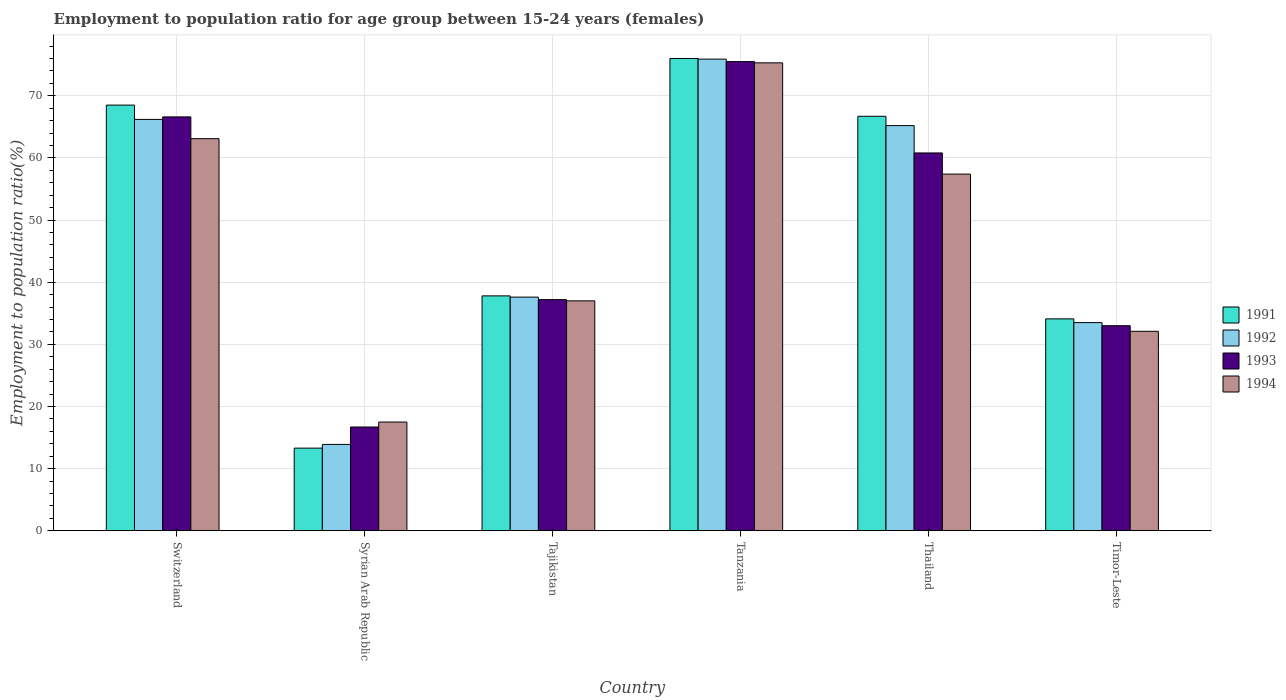How many different coloured bars are there?
Provide a succinct answer. 4. How many groups of bars are there?
Offer a very short reply. 6. Are the number of bars per tick equal to the number of legend labels?
Provide a short and direct response. Yes. How many bars are there on the 6th tick from the right?
Your answer should be compact. 4. What is the label of the 3rd group of bars from the left?
Your answer should be very brief. Tajikistan. Across all countries, what is the maximum employment to population ratio in 1994?
Keep it short and to the point. 75.3. Across all countries, what is the minimum employment to population ratio in 1992?
Offer a terse response. 13.9. In which country was the employment to population ratio in 1993 maximum?
Offer a terse response. Tanzania. In which country was the employment to population ratio in 1991 minimum?
Ensure brevity in your answer.  Syrian Arab Republic. What is the total employment to population ratio in 1991 in the graph?
Provide a short and direct response. 296.4. What is the difference between the employment to population ratio in 1991 in Tajikistan and that in Thailand?
Offer a very short reply. -28.9. What is the difference between the employment to population ratio in 1992 in Tajikistan and the employment to population ratio in 1994 in Timor-Leste?
Offer a very short reply. 5.5. What is the average employment to population ratio in 1992 per country?
Offer a very short reply. 48.72. What is the difference between the employment to population ratio of/in 1991 and employment to population ratio of/in 1993 in Thailand?
Provide a short and direct response. 5.9. In how many countries, is the employment to population ratio in 1991 greater than 26 %?
Provide a succinct answer. 5. What is the ratio of the employment to population ratio in 1991 in Switzerland to that in Thailand?
Your response must be concise. 1.03. Is the employment to population ratio in 1994 in Switzerland less than that in Thailand?
Provide a short and direct response. No. Is the difference between the employment to population ratio in 1991 in Tajikistan and Thailand greater than the difference between the employment to population ratio in 1993 in Tajikistan and Thailand?
Provide a succinct answer. No. What is the difference between the highest and the second highest employment to population ratio in 1993?
Keep it short and to the point. -8.9. What is the difference between the highest and the lowest employment to population ratio in 1991?
Offer a very short reply. 62.7. What does the 2nd bar from the left in Thailand represents?
Provide a succinct answer. 1992. What does the 1st bar from the right in Timor-Leste represents?
Give a very brief answer. 1994. Is it the case that in every country, the sum of the employment to population ratio in 1991 and employment to population ratio in 1992 is greater than the employment to population ratio in 1994?
Your answer should be compact. Yes. How many bars are there?
Your answer should be very brief. 24. Are all the bars in the graph horizontal?
Give a very brief answer. No. How many countries are there in the graph?
Offer a very short reply. 6. Are the values on the major ticks of Y-axis written in scientific E-notation?
Provide a short and direct response. No. Does the graph contain any zero values?
Give a very brief answer. No. Does the graph contain grids?
Your answer should be very brief. Yes. Where does the legend appear in the graph?
Your answer should be compact. Center right. How many legend labels are there?
Your answer should be compact. 4. How are the legend labels stacked?
Your response must be concise. Vertical. What is the title of the graph?
Provide a succinct answer. Employment to population ratio for age group between 15-24 years (females). What is the label or title of the X-axis?
Your response must be concise. Country. What is the label or title of the Y-axis?
Offer a very short reply. Employment to population ratio(%). What is the Employment to population ratio(%) of 1991 in Switzerland?
Ensure brevity in your answer.  68.5. What is the Employment to population ratio(%) of 1992 in Switzerland?
Ensure brevity in your answer.  66.2. What is the Employment to population ratio(%) of 1993 in Switzerland?
Give a very brief answer. 66.6. What is the Employment to population ratio(%) of 1994 in Switzerland?
Offer a terse response. 63.1. What is the Employment to population ratio(%) of 1991 in Syrian Arab Republic?
Your answer should be very brief. 13.3. What is the Employment to population ratio(%) of 1992 in Syrian Arab Republic?
Provide a short and direct response. 13.9. What is the Employment to population ratio(%) in 1993 in Syrian Arab Republic?
Make the answer very short. 16.7. What is the Employment to population ratio(%) of 1994 in Syrian Arab Republic?
Provide a succinct answer. 17.5. What is the Employment to population ratio(%) in 1991 in Tajikistan?
Keep it short and to the point. 37.8. What is the Employment to population ratio(%) in 1992 in Tajikistan?
Provide a short and direct response. 37.6. What is the Employment to population ratio(%) in 1993 in Tajikistan?
Provide a short and direct response. 37.2. What is the Employment to population ratio(%) in 1991 in Tanzania?
Provide a succinct answer. 76. What is the Employment to population ratio(%) of 1992 in Tanzania?
Offer a very short reply. 75.9. What is the Employment to population ratio(%) in 1993 in Tanzania?
Your answer should be very brief. 75.5. What is the Employment to population ratio(%) in 1994 in Tanzania?
Give a very brief answer. 75.3. What is the Employment to population ratio(%) in 1991 in Thailand?
Make the answer very short. 66.7. What is the Employment to population ratio(%) of 1992 in Thailand?
Offer a very short reply. 65.2. What is the Employment to population ratio(%) in 1993 in Thailand?
Your answer should be compact. 60.8. What is the Employment to population ratio(%) of 1994 in Thailand?
Provide a short and direct response. 57.4. What is the Employment to population ratio(%) in 1991 in Timor-Leste?
Give a very brief answer. 34.1. What is the Employment to population ratio(%) in 1992 in Timor-Leste?
Provide a succinct answer. 33.5. What is the Employment to population ratio(%) in 1994 in Timor-Leste?
Your response must be concise. 32.1. Across all countries, what is the maximum Employment to population ratio(%) in 1991?
Your response must be concise. 76. Across all countries, what is the maximum Employment to population ratio(%) in 1992?
Offer a very short reply. 75.9. Across all countries, what is the maximum Employment to population ratio(%) of 1993?
Make the answer very short. 75.5. Across all countries, what is the maximum Employment to population ratio(%) in 1994?
Your response must be concise. 75.3. Across all countries, what is the minimum Employment to population ratio(%) of 1991?
Your answer should be compact. 13.3. Across all countries, what is the minimum Employment to population ratio(%) of 1992?
Ensure brevity in your answer.  13.9. Across all countries, what is the minimum Employment to population ratio(%) in 1993?
Provide a short and direct response. 16.7. Across all countries, what is the minimum Employment to population ratio(%) of 1994?
Give a very brief answer. 17.5. What is the total Employment to population ratio(%) in 1991 in the graph?
Your answer should be compact. 296.4. What is the total Employment to population ratio(%) in 1992 in the graph?
Keep it short and to the point. 292.3. What is the total Employment to population ratio(%) in 1993 in the graph?
Make the answer very short. 289.8. What is the total Employment to population ratio(%) of 1994 in the graph?
Offer a very short reply. 282.4. What is the difference between the Employment to population ratio(%) of 1991 in Switzerland and that in Syrian Arab Republic?
Make the answer very short. 55.2. What is the difference between the Employment to population ratio(%) in 1992 in Switzerland and that in Syrian Arab Republic?
Your answer should be very brief. 52.3. What is the difference between the Employment to population ratio(%) of 1993 in Switzerland and that in Syrian Arab Republic?
Offer a terse response. 49.9. What is the difference between the Employment to population ratio(%) in 1994 in Switzerland and that in Syrian Arab Republic?
Offer a very short reply. 45.6. What is the difference between the Employment to population ratio(%) in 1991 in Switzerland and that in Tajikistan?
Provide a short and direct response. 30.7. What is the difference between the Employment to population ratio(%) of 1992 in Switzerland and that in Tajikistan?
Your answer should be compact. 28.6. What is the difference between the Employment to population ratio(%) in 1993 in Switzerland and that in Tajikistan?
Your response must be concise. 29.4. What is the difference between the Employment to population ratio(%) in 1994 in Switzerland and that in Tajikistan?
Provide a succinct answer. 26.1. What is the difference between the Employment to population ratio(%) of 1991 in Switzerland and that in Tanzania?
Your response must be concise. -7.5. What is the difference between the Employment to population ratio(%) of 1992 in Switzerland and that in Tanzania?
Offer a terse response. -9.7. What is the difference between the Employment to population ratio(%) in 1993 in Switzerland and that in Tanzania?
Provide a short and direct response. -8.9. What is the difference between the Employment to population ratio(%) in 1994 in Switzerland and that in Thailand?
Offer a very short reply. 5.7. What is the difference between the Employment to population ratio(%) of 1991 in Switzerland and that in Timor-Leste?
Make the answer very short. 34.4. What is the difference between the Employment to population ratio(%) in 1992 in Switzerland and that in Timor-Leste?
Provide a succinct answer. 32.7. What is the difference between the Employment to population ratio(%) of 1993 in Switzerland and that in Timor-Leste?
Offer a very short reply. 33.6. What is the difference between the Employment to population ratio(%) in 1991 in Syrian Arab Republic and that in Tajikistan?
Make the answer very short. -24.5. What is the difference between the Employment to population ratio(%) of 1992 in Syrian Arab Republic and that in Tajikistan?
Your answer should be compact. -23.7. What is the difference between the Employment to population ratio(%) of 1993 in Syrian Arab Republic and that in Tajikistan?
Provide a succinct answer. -20.5. What is the difference between the Employment to population ratio(%) of 1994 in Syrian Arab Republic and that in Tajikistan?
Provide a succinct answer. -19.5. What is the difference between the Employment to population ratio(%) of 1991 in Syrian Arab Republic and that in Tanzania?
Offer a terse response. -62.7. What is the difference between the Employment to population ratio(%) of 1992 in Syrian Arab Republic and that in Tanzania?
Your response must be concise. -62. What is the difference between the Employment to population ratio(%) in 1993 in Syrian Arab Republic and that in Tanzania?
Provide a succinct answer. -58.8. What is the difference between the Employment to population ratio(%) in 1994 in Syrian Arab Republic and that in Tanzania?
Your answer should be very brief. -57.8. What is the difference between the Employment to population ratio(%) in 1991 in Syrian Arab Republic and that in Thailand?
Provide a short and direct response. -53.4. What is the difference between the Employment to population ratio(%) of 1992 in Syrian Arab Republic and that in Thailand?
Ensure brevity in your answer.  -51.3. What is the difference between the Employment to population ratio(%) of 1993 in Syrian Arab Republic and that in Thailand?
Offer a very short reply. -44.1. What is the difference between the Employment to population ratio(%) of 1994 in Syrian Arab Republic and that in Thailand?
Give a very brief answer. -39.9. What is the difference between the Employment to population ratio(%) of 1991 in Syrian Arab Republic and that in Timor-Leste?
Keep it short and to the point. -20.8. What is the difference between the Employment to population ratio(%) of 1992 in Syrian Arab Republic and that in Timor-Leste?
Your answer should be compact. -19.6. What is the difference between the Employment to population ratio(%) of 1993 in Syrian Arab Republic and that in Timor-Leste?
Provide a succinct answer. -16.3. What is the difference between the Employment to population ratio(%) in 1994 in Syrian Arab Republic and that in Timor-Leste?
Your answer should be compact. -14.6. What is the difference between the Employment to population ratio(%) of 1991 in Tajikistan and that in Tanzania?
Your answer should be compact. -38.2. What is the difference between the Employment to population ratio(%) of 1992 in Tajikistan and that in Tanzania?
Your answer should be compact. -38.3. What is the difference between the Employment to population ratio(%) of 1993 in Tajikistan and that in Tanzania?
Provide a succinct answer. -38.3. What is the difference between the Employment to population ratio(%) in 1994 in Tajikistan and that in Tanzania?
Make the answer very short. -38.3. What is the difference between the Employment to population ratio(%) in 1991 in Tajikistan and that in Thailand?
Provide a short and direct response. -28.9. What is the difference between the Employment to population ratio(%) of 1992 in Tajikistan and that in Thailand?
Ensure brevity in your answer.  -27.6. What is the difference between the Employment to population ratio(%) of 1993 in Tajikistan and that in Thailand?
Ensure brevity in your answer.  -23.6. What is the difference between the Employment to population ratio(%) in 1994 in Tajikistan and that in Thailand?
Your response must be concise. -20.4. What is the difference between the Employment to population ratio(%) of 1992 in Tajikistan and that in Timor-Leste?
Your response must be concise. 4.1. What is the difference between the Employment to population ratio(%) of 1993 in Tajikistan and that in Timor-Leste?
Offer a very short reply. 4.2. What is the difference between the Employment to population ratio(%) of 1994 in Tajikistan and that in Timor-Leste?
Your answer should be very brief. 4.9. What is the difference between the Employment to population ratio(%) in 1991 in Tanzania and that in Thailand?
Offer a terse response. 9.3. What is the difference between the Employment to population ratio(%) in 1992 in Tanzania and that in Thailand?
Your answer should be compact. 10.7. What is the difference between the Employment to population ratio(%) in 1993 in Tanzania and that in Thailand?
Give a very brief answer. 14.7. What is the difference between the Employment to population ratio(%) in 1994 in Tanzania and that in Thailand?
Your answer should be compact. 17.9. What is the difference between the Employment to population ratio(%) of 1991 in Tanzania and that in Timor-Leste?
Provide a succinct answer. 41.9. What is the difference between the Employment to population ratio(%) of 1992 in Tanzania and that in Timor-Leste?
Provide a short and direct response. 42.4. What is the difference between the Employment to population ratio(%) of 1993 in Tanzania and that in Timor-Leste?
Offer a terse response. 42.5. What is the difference between the Employment to population ratio(%) in 1994 in Tanzania and that in Timor-Leste?
Ensure brevity in your answer.  43.2. What is the difference between the Employment to population ratio(%) of 1991 in Thailand and that in Timor-Leste?
Ensure brevity in your answer.  32.6. What is the difference between the Employment to population ratio(%) of 1992 in Thailand and that in Timor-Leste?
Give a very brief answer. 31.7. What is the difference between the Employment to population ratio(%) of 1993 in Thailand and that in Timor-Leste?
Your answer should be very brief. 27.8. What is the difference between the Employment to population ratio(%) of 1994 in Thailand and that in Timor-Leste?
Provide a succinct answer. 25.3. What is the difference between the Employment to population ratio(%) in 1991 in Switzerland and the Employment to population ratio(%) in 1992 in Syrian Arab Republic?
Offer a terse response. 54.6. What is the difference between the Employment to population ratio(%) of 1991 in Switzerland and the Employment to population ratio(%) of 1993 in Syrian Arab Republic?
Your answer should be very brief. 51.8. What is the difference between the Employment to population ratio(%) of 1992 in Switzerland and the Employment to population ratio(%) of 1993 in Syrian Arab Republic?
Your answer should be compact. 49.5. What is the difference between the Employment to population ratio(%) in 1992 in Switzerland and the Employment to population ratio(%) in 1994 in Syrian Arab Republic?
Your response must be concise. 48.7. What is the difference between the Employment to population ratio(%) in 1993 in Switzerland and the Employment to population ratio(%) in 1994 in Syrian Arab Republic?
Provide a short and direct response. 49.1. What is the difference between the Employment to population ratio(%) in 1991 in Switzerland and the Employment to population ratio(%) in 1992 in Tajikistan?
Give a very brief answer. 30.9. What is the difference between the Employment to population ratio(%) of 1991 in Switzerland and the Employment to population ratio(%) of 1993 in Tajikistan?
Offer a very short reply. 31.3. What is the difference between the Employment to population ratio(%) in 1991 in Switzerland and the Employment to population ratio(%) in 1994 in Tajikistan?
Provide a short and direct response. 31.5. What is the difference between the Employment to population ratio(%) of 1992 in Switzerland and the Employment to population ratio(%) of 1993 in Tajikistan?
Provide a succinct answer. 29. What is the difference between the Employment to population ratio(%) in 1992 in Switzerland and the Employment to population ratio(%) in 1994 in Tajikistan?
Offer a very short reply. 29.2. What is the difference between the Employment to population ratio(%) in 1993 in Switzerland and the Employment to population ratio(%) in 1994 in Tajikistan?
Make the answer very short. 29.6. What is the difference between the Employment to population ratio(%) of 1991 in Switzerland and the Employment to population ratio(%) of 1992 in Tanzania?
Give a very brief answer. -7.4. What is the difference between the Employment to population ratio(%) in 1991 in Switzerland and the Employment to population ratio(%) in 1993 in Tanzania?
Your answer should be compact. -7. What is the difference between the Employment to population ratio(%) in 1992 in Switzerland and the Employment to population ratio(%) in 1993 in Tanzania?
Make the answer very short. -9.3. What is the difference between the Employment to population ratio(%) in 1991 in Switzerland and the Employment to population ratio(%) in 1994 in Thailand?
Your response must be concise. 11.1. What is the difference between the Employment to population ratio(%) in 1992 in Switzerland and the Employment to population ratio(%) in 1993 in Thailand?
Ensure brevity in your answer.  5.4. What is the difference between the Employment to population ratio(%) of 1992 in Switzerland and the Employment to population ratio(%) of 1994 in Thailand?
Your answer should be compact. 8.8. What is the difference between the Employment to population ratio(%) in 1991 in Switzerland and the Employment to population ratio(%) in 1992 in Timor-Leste?
Your response must be concise. 35. What is the difference between the Employment to population ratio(%) in 1991 in Switzerland and the Employment to population ratio(%) in 1993 in Timor-Leste?
Offer a very short reply. 35.5. What is the difference between the Employment to population ratio(%) of 1991 in Switzerland and the Employment to population ratio(%) of 1994 in Timor-Leste?
Provide a short and direct response. 36.4. What is the difference between the Employment to population ratio(%) of 1992 in Switzerland and the Employment to population ratio(%) of 1993 in Timor-Leste?
Keep it short and to the point. 33.2. What is the difference between the Employment to population ratio(%) in 1992 in Switzerland and the Employment to population ratio(%) in 1994 in Timor-Leste?
Provide a succinct answer. 34.1. What is the difference between the Employment to population ratio(%) in 1993 in Switzerland and the Employment to population ratio(%) in 1994 in Timor-Leste?
Provide a short and direct response. 34.5. What is the difference between the Employment to population ratio(%) of 1991 in Syrian Arab Republic and the Employment to population ratio(%) of 1992 in Tajikistan?
Offer a terse response. -24.3. What is the difference between the Employment to population ratio(%) of 1991 in Syrian Arab Republic and the Employment to population ratio(%) of 1993 in Tajikistan?
Make the answer very short. -23.9. What is the difference between the Employment to population ratio(%) of 1991 in Syrian Arab Republic and the Employment to population ratio(%) of 1994 in Tajikistan?
Your response must be concise. -23.7. What is the difference between the Employment to population ratio(%) of 1992 in Syrian Arab Republic and the Employment to population ratio(%) of 1993 in Tajikistan?
Provide a succinct answer. -23.3. What is the difference between the Employment to population ratio(%) of 1992 in Syrian Arab Republic and the Employment to population ratio(%) of 1994 in Tajikistan?
Your response must be concise. -23.1. What is the difference between the Employment to population ratio(%) of 1993 in Syrian Arab Republic and the Employment to population ratio(%) of 1994 in Tajikistan?
Provide a succinct answer. -20.3. What is the difference between the Employment to population ratio(%) of 1991 in Syrian Arab Republic and the Employment to population ratio(%) of 1992 in Tanzania?
Your answer should be compact. -62.6. What is the difference between the Employment to population ratio(%) of 1991 in Syrian Arab Republic and the Employment to population ratio(%) of 1993 in Tanzania?
Your answer should be very brief. -62.2. What is the difference between the Employment to population ratio(%) in 1991 in Syrian Arab Republic and the Employment to population ratio(%) in 1994 in Tanzania?
Your response must be concise. -62. What is the difference between the Employment to population ratio(%) of 1992 in Syrian Arab Republic and the Employment to population ratio(%) of 1993 in Tanzania?
Your answer should be very brief. -61.6. What is the difference between the Employment to population ratio(%) in 1992 in Syrian Arab Republic and the Employment to population ratio(%) in 1994 in Tanzania?
Offer a terse response. -61.4. What is the difference between the Employment to population ratio(%) in 1993 in Syrian Arab Republic and the Employment to population ratio(%) in 1994 in Tanzania?
Your response must be concise. -58.6. What is the difference between the Employment to population ratio(%) of 1991 in Syrian Arab Republic and the Employment to population ratio(%) of 1992 in Thailand?
Keep it short and to the point. -51.9. What is the difference between the Employment to population ratio(%) of 1991 in Syrian Arab Republic and the Employment to population ratio(%) of 1993 in Thailand?
Offer a terse response. -47.5. What is the difference between the Employment to population ratio(%) in 1991 in Syrian Arab Republic and the Employment to population ratio(%) in 1994 in Thailand?
Offer a terse response. -44.1. What is the difference between the Employment to population ratio(%) in 1992 in Syrian Arab Republic and the Employment to population ratio(%) in 1993 in Thailand?
Offer a very short reply. -46.9. What is the difference between the Employment to population ratio(%) in 1992 in Syrian Arab Republic and the Employment to population ratio(%) in 1994 in Thailand?
Your answer should be compact. -43.5. What is the difference between the Employment to population ratio(%) of 1993 in Syrian Arab Republic and the Employment to population ratio(%) of 1994 in Thailand?
Your answer should be compact. -40.7. What is the difference between the Employment to population ratio(%) in 1991 in Syrian Arab Republic and the Employment to population ratio(%) in 1992 in Timor-Leste?
Give a very brief answer. -20.2. What is the difference between the Employment to population ratio(%) in 1991 in Syrian Arab Republic and the Employment to population ratio(%) in 1993 in Timor-Leste?
Provide a succinct answer. -19.7. What is the difference between the Employment to population ratio(%) of 1991 in Syrian Arab Republic and the Employment to population ratio(%) of 1994 in Timor-Leste?
Keep it short and to the point. -18.8. What is the difference between the Employment to population ratio(%) in 1992 in Syrian Arab Republic and the Employment to population ratio(%) in 1993 in Timor-Leste?
Make the answer very short. -19.1. What is the difference between the Employment to population ratio(%) of 1992 in Syrian Arab Republic and the Employment to population ratio(%) of 1994 in Timor-Leste?
Your response must be concise. -18.2. What is the difference between the Employment to population ratio(%) of 1993 in Syrian Arab Republic and the Employment to population ratio(%) of 1994 in Timor-Leste?
Ensure brevity in your answer.  -15.4. What is the difference between the Employment to population ratio(%) of 1991 in Tajikistan and the Employment to population ratio(%) of 1992 in Tanzania?
Ensure brevity in your answer.  -38.1. What is the difference between the Employment to population ratio(%) in 1991 in Tajikistan and the Employment to population ratio(%) in 1993 in Tanzania?
Provide a succinct answer. -37.7. What is the difference between the Employment to population ratio(%) of 1991 in Tajikistan and the Employment to population ratio(%) of 1994 in Tanzania?
Provide a short and direct response. -37.5. What is the difference between the Employment to population ratio(%) of 1992 in Tajikistan and the Employment to population ratio(%) of 1993 in Tanzania?
Your response must be concise. -37.9. What is the difference between the Employment to population ratio(%) of 1992 in Tajikistan and the Employment to population ratio(%) of 1994 in Tanzania?
Make the answer very short. -37.7. What is the difference between the Employment to population ratio(%) in 1993 in Tajikistan and the Employment to population ratio(%) in 1994 in Tanzania?
Your answer should be very brief. -38.1. What is the difference between the Employment to population ratio(%) of 1991 in Tajikistan and the Employment to population ratio(%) of 1992 in Thailand?
Your response must be concise. -27.4. What is the difference between the Employment to population ratio(%) of 1991 in Tajikistan and the Employment to population ratio(%) of 1994 in Thailand?
Provide a succinct answer. -19.6. What is the difference between the Employment to population ratio(%) in 1992 in Tajikistan and the Employment to population ratio(%) in 1993 in Thailand?
Your response must be concise. -23.2. What is the difference between the Employment to population ratio(%) of 1992 in Tajikistan and the Employment to population ratio(%) of 1994 in Thailand?
Keep it short and to the point. -19.8. What is the difference between the Employment to population ratio(%) in 1993 in Tajikistan and the Employment to population ratio(%) in 1994 in Thailand?
Provide a short and direct response. -20.2. What is the difference between the Employment to population ratio(%) in 1991 in Tajikistan and the Employment to population ratio(%) in 1994 in Timor-Leste?
Your answer should be compact. 5.7. What is the difference between the Employment to population ratio(%) in 1993 in Tajikistan and the Employment to population ratio(%) in 1994 in Timor-Leste?
Provide a short and direct response. 5.1. What is the difference between the Employment to population ratio(%) in 1991 in Tanzania and the Employment to population ratio(%) in 1993 in Thailand?
Your answer should be compact. 15.2. What is the difference between the Employment to population ratio(%) of 1991 in Tanzania and the Employment to population ratio(%) of 1994 in Thailand?
Make the answer very short. 18.6. What is the difference between the Employment to population ratio(%) in 1992 in Tanzania and the Employment to population ratio(%) in 1993 in Thailand?
Your answer should be compact. 15.1. What is the difference between the Employment to population ratio(%) in 1993 in Tanzania and the Employment to population ratio(%) in 1994 in Thailand?
Give a very brief answer. 18.1. What is the difference between the Employment to population ratio(%) in 1991 in Tanzania and the Employment to population ratio(%) in 1992 in Timor-Leste?
Give a very brief answer. 42.5. What is the difference between the Employment to population ratio(%) of 1991 in Tanzania and the Employment to population ratio(%) of 1994 in Timor-Leste?
Keep it short and to the point. 43.9. What is the difference between the Employment to population ratio(%) of 1992 in Tanzania and the Employment to population ratio(%) of 1993 in Timor-Leste?
Your answer should be very brief. 42.9. What is the difference between the Employment to population ratio(%) of 1992 in Tanzania and the Employment to population ratio(%) of 1994 in Timor-Leste?
Offer a very short reply. 43.8. What is the difference between the Employment to population ratio(%) of 1993 in Tanzania and the Employment to population ratio(%) of 1994 in Timor-Leste?
Ensure brevity in your answer.  43.4. What is the difference between the Employment to population ratio(%) in 1991 in Thailand and the Employment to population ratio(%) in 1992 in Timor-Leste?
Keep it short and to the point. 33.2. What is the difference between the Employment to population ratio(%) of 1991 in Thailand and the Employment to population ratio(%) of 1993 in Timor-Leste?
Keep it short and to the point. 33.7. What is the difference between the Employment to population ratio(%) in 1991 in Thailand and the Employment to population ratio(%) in 1994 in Timor-Leste?
Give a very brief answer. 34.6. What is the difference between the Employment to population ratio(%) of 1992 in Thailand and the Employment to population ratio(%) of 1993 in Timor-Leste?
Your answer should be very brief. 32.2. What is the difference between the Employment to population ratio(%) in 1992 in Thailand and the Employment to population ratio(%) in 1994 in Timor-Leste?
Provide a short and direct response. 33.1. What is the difference between the Employment to population ratio(%) of 1993 in Thailand and the Employment to population ratio(%) of 1994 in Timor-Leste?
Give a very brief answer. 28.7. What is the average Employment to population ratio(%) in 1991 per country?
Give a very brief answer. 49.4. What is the average Employment to population ratio(%) of 1992 per country?
Your response must be concise. 48.72. What is the average Employment to population ratio(%) in 1993 per country?
Provide a succinct answer. 48.3. What is the average Employment to population ratio(%) in 1994 per country?
Offer a very short reply. 47.07. What is the difference between the Employment to population ratio(%) of 1991 and Employment to population ratio(%) of 1993 in Switzerland?
Your answer should be very brief. 1.9. What is the difference between the Employment to population ratio(%) of 1991 and Employment to population ratio(%) of 1994 in Switzerland?
Your response must be concise. 5.4. What is the difference between the Employment to population ratio(%) of 1992 and Employment to population ratio(%) of 1993 in Switzerland?
Make the answer very short. -0.4. What is the difference between the Employment to population ratio(%) of 1992 and Employment to population ratio(%) of 1994 in Switzerland?
Offer a very short reply. 3.1. What is the difference between the Employment to population ratio(%) in 1993 and Employment to population ratio(%) in 1994 in Switzerland?
Make the answer very short. 3.5. What is the difference between the Employment to population ratio(%) in 1991 and Employment to population ratio(%) in 1992 in Syrian Arab Republic?
Make the answer very short. -0.6. What is the difference between the Employment to population ratio(%) in 1991 and Employment to population ratio(%) in 1994 in Syrian Arab Republic?
Provide a succinct answer. -4.2. What is the difference between the Employment to population ratio(%) in 1992 and Employment to population ratio(%) in 1993 in Syrian Arab Republic?
Keep it short and to the point. -2.8. What is the difference between the Employment to population ratio(%) of 1992 and Employment to population ratio(%) of 1994 in Syrian Arab Republic?
Your answer should be compact. -3.6. What is the difference between the Employment to population ratio(%) in 1993 and Employment to population ratio(%) in 1994 in Syrian Arab Republic?
Offer a terse response. -0.8. What is the difference between the Employment to population ratio(%) in 1991 and Employment to population ratio(%) in 1992 in Tajikistan?
Keep it short and to the point. 0.2. What is the difference between the Employment to population ratio(%) of 1991 and Employment to population ratio(%) of 1993 in Tajikistan?
Ensure brevity in your answer.  0.6. What is the difference between the Employment to population ratio(%) in 1991 and Employment to population ratio(%) in 1992 in Tanzania?
Offer a very short reply. 0.1. What is the difference between the Employment to population ratio(%) in 1991 and Employment to population ratio(%) in 1994 in Tanzania?
Your answer should be compact. 0.7. What is the difference between the Employment to population ratio(%) in 1992 and Employment to population ratio(%) in 1994 in Tanzania?
Provide a short and direct response. 0.6. What is the difference between the Employment to population ratio(%) in 1991 and Employment to population ratio(%) in 1992 in Thailand?
Offer a very short reply. 1.5. What is the difference between the Employment to population ratio(%) in 1991 and Employment to population ratio(%) in 1993 in Thailand?
Offer a very short reply. 5.9. What is the difference between the Employment to population ratio(%) of 1991 and Employment to population ratio(%) of 1994 in Thailand?
Offer a very short reply. 9.3. What is the difference between the Employment to population ratio(%) of 1992 and Employment to population ratio(%) of 1993 in Thailand?
Your answer should be very brief. 4.4. What is the difference between the Employment to population ratio(%) of 1992 and Employment to population ratio(%) of 1993 in Timor-Leste?
Give a very brief answer. 0.5. What is the ratio of the Employment to population ratio(%) in 1991 in Switzerland to that in Syrian Arab Republic?
Your answer should be very brief. 5.15. What is the ratio of the Employment to population ratio(%) of 1992 in Switzerland to that in Syrian Arab Republic?
Give a very brief answer. 4.76. What is the ratio of the Employment to population ratio(%) of 1993 in Switzerland to that in Syrian Arab Republic?
Provide a succinct answer. 3.99. What is the ratio of the Employment to population ratio(%) in 1994 in Switzerland to that in Syrian Arab Republic?
Offer a terse response. 3.61. What is the ratio of the Employment to population ratio(%) of 1991 in Switzerland to that in Tajikistan?
Your answer should be very brief. 1.81. What is the ratio of the Employment to population ratio(%) in 1992 in Switzerland to that in Tajikistan?
Your response must be concise. 1.76. What is the ratio of the Employment to population ratio(%) of 1993 in Switzerland to that in Tajikistan?
Provide a short and direct response. 1.79. What is the ratio of the Employment to population ratio(%) in 1994 in Switzerland to that in Tajikistan?
Provide a succinct answer. 1.71. What is the ratio of the Employment to population ratio(%) in 1991 in Switzerland to that in Tanzania?
Ensure brevity in your answer.  0.9. What is the ratio of the Employment to population ratio(%) of 1992 in Switzerland to that in Tanzania?
Your answer should be compact. 0.87. What is the ratio of the Employment to population ratio(%) of 1993 in Switzerland to that in Tanzania?
Provide a short and direct response. 0.88. What is the ratio of the Employment to population ratio(%) in 1994 in Switzerland to that in Tanzania?
Ensure brevity in your answer.  0.84. What is the ratio of the Employment to population ratio(%) in 1991 in Switzerland to that in Thailand?
Offer a very short reply. 1.03. What is the ratio of the Employment to population ratio(%) of 1992 in Switzerland to that in Thailand?
Keep it short and to the point. 1.02. What is the ratio of the Employment to population ratio(%) in 1993 in Switzerland to that in Thailand?
Give a very brief answer. 1.1. What is the ratio of the Employment to population ratio(%) of 1994 in Switzerland to that in Thailand?
Your answer should be compact. 1.1. What is the ratio of the Employment to population ratio(%) of 1991 in Switzerland to that in Timor-Leste?
Your answer should be compact. 2.01. What is the ratio of the Employment to population ratio(%) in 1992 in Switzerland to that in Timor-Leste?
Offer a terse response. 1.98. What is the ratio of the Employment to population ratio(%) of 1993 in Switzerland to that in Timor-Leste?
Ensure brevity in your answer.  2.02. What is the ratio of the Employment to population ratio(%) of 1994 in Switzerland to that in Timor-Leste?
Your answer should be compact. 1.97. What is the ratio of the Employment to population ratio(%) of 1991 in Syrian Arab Republic to that in Tajikistan?
Ensure brevity in your answer.  0.35. What is the ratio of the Employment to population ratio(%) of 1992 in Syrian Arab Republic to that in Tajikistan?
Offer a terse response. 0.37. What is the ratio of the Employment to population ratio(%) in 1993 in Syrian Arab Republic to that in Tajikistan?
Give a very brief answer. 0.45. What is the ratio of the Employment to population ratio(%) in 1994 in Syrian Arab Republic to that in Tajikistan?
Offer a terse response. 0.47. What is the ratio of the Employment to population ratio(%) of 1991 in Syrian Arab Republic to that in Tanzania?
Your answer should be very brief. 0.17. What is the ratio of the Employment to population ratio(%) in 1992 in Syrian Arab Republic to that in Tanzania?
Offer a very short reply. 0.18. What is the ratio of the Employment to population ratio(%) in 1993 in Syrian Arab Republic to that in Tanzania?
Your answer should be compact. 0.22. What is the ratio of the Employment to population ratio(%) of 1994 in Syrian Arab Republic to that in Tanzania?
Your response must be concise. 0.23. What is the ratio of the Employment to population ratio(%) in 1991 in Syrian Arab Republic to that in Thailand?
Make the answer very short. 0.2. What is the ratio of the Employment to population ratio(%) in 1992 in Syrian Arab Republic to that in Thailand?
Ensure brevity in your answer.  0.21. What is the ratio of the Employment to population ratio(%) in 1993 in Syrian Arab Republic to that in Thailand?
Provide a succinct answer. 0.27. What is the ratio of the Employment to population ratio(%) in 1994 in Syrian Arab Republic to that in Thailand?
Offer a very short reply. 0.3. What is the ratio of the Employment to population ratio(%) in 1991 in Syrian Arab Republic to that in Timor-Leste?
Give a very brief answer. 0.39. What is the ratio of the Employment to population ratio(%) in 1992 in Syrian Arab Republic to that in Timor-Leste?
Give a very brief answer. 0.41. What is the ratio of the Employment to population ratio(%) in 1993 in Syrian Arab Republic to that in Timor-Leste?
Your answer should be compact. 0.51. What is the ratio of the Employment to population ratio(%) of 1994 in Syrian Arab Republic to that in Timor-Leste?
Provide a short and direct response. 0.55. What is the ratio of the Employment to population ratio(%) in 1991 in Tajikistan to that in Tanzania?
Ensure brevity in your answer.  0.5. What is the ratio of the Employment to population ratio(%) of 1992 in Tajikistan to that in Tanzania?
Offer a terse response. 0.5. What is the ratio of the Employment to population ratio(%) in 1993 in Tajikistan to that in Tanzania?
Offer a terse response. 0.49. What is the ratio of the Employment to population ratio(%) in 1994 in Tajikistan to that in Tanzania?
Your answer should be compact. 0.49. What is the ratio of the Employment to population ratio(%) of 1991 in Tajikistan to that in Thailand?
Your response must be concise. 0.57. What is the ratio of the Employment to population ratio(%) in 1992 in Tajikistan to that in Thailand?
Provide a short and direct response. 0.58. What is the ratio of the Employment to population ratio(%) in 1993 in Tajikistan to that in Thailand?
Your answer should be compact. 0.61. What is the ratio of the Employment to population ratio(%) of 1994 in Tajikistan to that in Thailand?
Offer a very short reply. 0.64. What is the ratio of the Employment to population ratio(%) in 1991 in Tajikistan to that in Timor-Leste?
Your answer should be very brief. 1.11. What is the ratio of the Employment to population ratio(%) of 1992 in Tajikistan to that in Timor-Leste?
Make the answer very short. 1.12. What is the ratio of the Employment to population ratio(%) of 1993 in Tajikistan to that in Timor-Leste?
Your answer should be compact. 1.13. What is the ratio of the Employment to population ratio(%) in 1994 in Tajikistan to that in Timor-Leste?
Offer a terse response. 1.15. What is the ratio of the Employment to population ratio(%) of 1991 in Tanzania to that in Thailand?
Your response must be concise. 1.14. What is the ratio of the Employment to population ratio(%) in 1992 in Tanzania to that in Thailand?
Offer a terse response. 1.16. What is the ratio of the Employment to population ratio(%) in 1993 in Tanzania to that in Thailand?
Give a very brief answer. 1.24. What is the ratio of the Employment to population ratio(%) in 1994 in Tanzania to that in Thailand?
Your response must be concise. 1.31. What is the ratio of the Employment to population ratio(%) in 1991 in Tanzania to that in Timor-Leste?
Give a very brief answer. 2.23. What is the ratio of the Employment to population ratio(%) in 1992 in Tanzania to that in Timor-Leste?
Your answer should be compact. 2.27. What is the ratio of the Employment to population ratio(%) in 1993 in Tanzania to that in Timor-Leste?
Offer a terse response. 2.29. What is the ratio of the Employment to population ratio(%) in 1994 in Tanzania to that in Timor-Leste?
Keep it short and to the point. 2.35. What is the ratio of the Employment to population ratio(%) of 1991 in Thailand to that in Timor-Leste?
Keep it short and to the point. 1.96. What is the ratio of the Employment to population ratio(%) in 1992 in Thailand to that in Timor-Leste?
Your response must be concise. 1.95. What is the ratio of the Employment to population ratio(%) of 1993 in Thailand to that in Timor-Leste?
Offer a very short reply. 1.84. What is the ratio of the Employment to population ratio(%) of 1994 in Thailand to that in Timor-Leste?
Your response must be concise. 1.79. What is the difference between the highest and the second highest Employment to population ratio(%) in 1993?
Ensure brevity in your answer.  8.9. What is the difference between the highest and the second highest Employment to population ratio(%) of 1994?
Provide a short and direct response. 12.2. What is the difference between the highest and the lowest Employment to population ratio(%) in 1991?
Your answer should be compact. 62.7. What is the difference between the highest and the lowest Employment to population ratio(%) of 1992?
Offer a very short reply. 62. What is the difference between the highest and the lowest Employment to population ratio(%) in 1993?
Your answer should be compact. 58.8. What is the difference between the highest and the lowest Employment to population ratio(%) of 1994?
Ensure brevity in your answer.  57.8. 